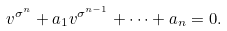Convert formula to latex. <formula><loc_0><loc_0><loc_500><loc_500>v ^ { \sigma ^ { n } } + a _ { 1 } v ^ { \sigma ^ { n - 1 } } + \cdots + a _ { n } = 0 .</formula> 